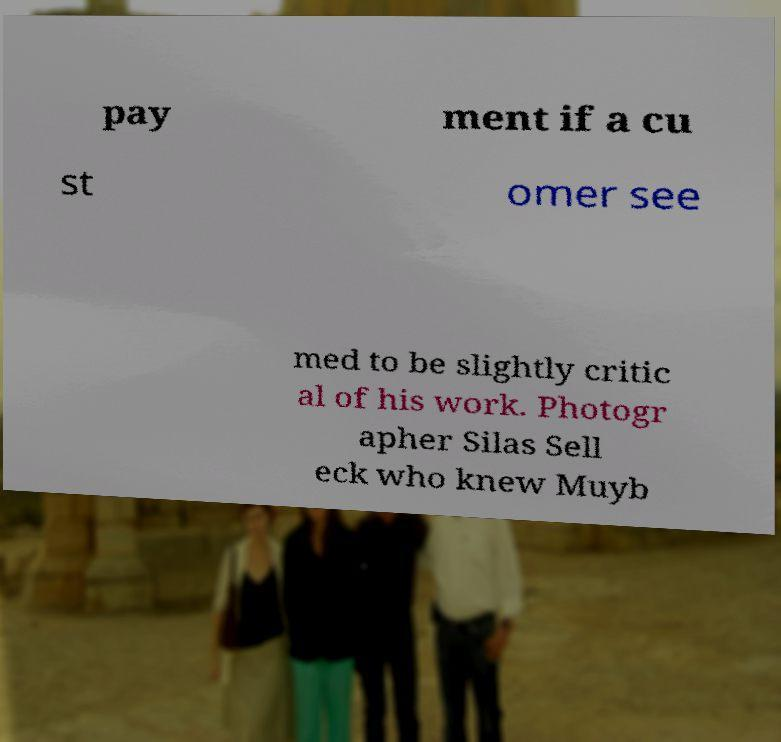Please read and relay the text visible in this image. What does it say? pay ment if a cu st omer see med to be slightly critic al of his work. Photogr apher Silas Sell eck who knew Muyb 